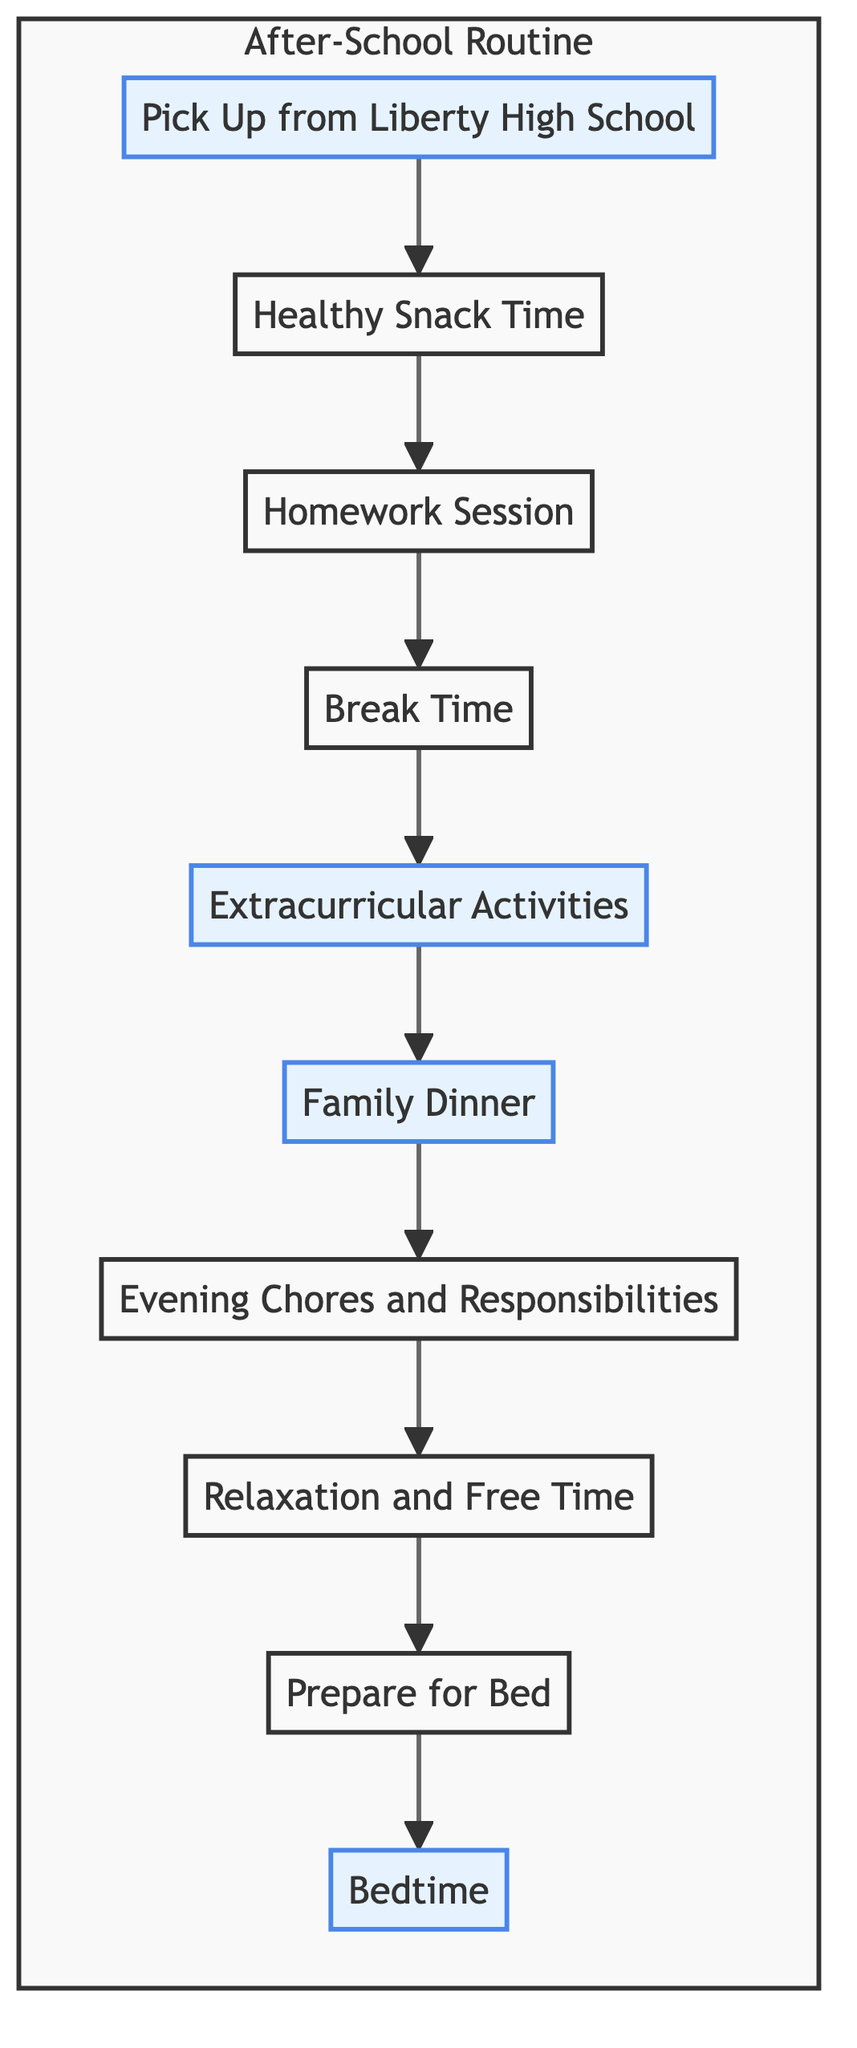What is the first step in the after-school routine? The first step is represented by the node labeled "Pick Up from Liberty High School." It is the starting point of the flowchart indicating where the routine begins.
Answer: Pick Up from Liberty High School How many steps are in the after-school routine? By counting the nodes in the flowchart, there are a total of 10 steps involved in the after-school routine.
Answer: 10 What follows the homework session? The node that follows "Homework Session" is "Break Time," which represents the next activity in the routine after completing homework.
Answer: Break Time Which activity is scheduled after family dinner? After "Family Dinner," the next step is "Evening Chores and Responsibilities," indicating those chores must be done afterward.
Answer: Evening Chores and Responsibilities What is the last step in the routine? The last step is "Bedtime," which signifies the end of the after-school routine, where the teen goes to bed.
Answer: Bedtime How many activities involve family interaction? The flowchart indicates that "Family Dinner" is the only activity that explicitly involves family interaction during the after-school routine.
Answer: 1 Which step allows for relaxation after homework? The step that enables relaxation following homework is "Break Time," designed for a brief pause before proceeding with activities.
Answer: Break Time What are the two activities highlighted in the diagram? The two highlighted activities are "Pick Up from Liberty High School" and "Bedtime," emphasizing their importance in the routine.
Answer: Pick Up from Liberty High School and Bedtime Which step encourages unwinding before bed? The step labeled "Relaxation and Free Time" encourages unwinding activities before proceeding to bedtime.
Answer: Relaxation and Free Time 